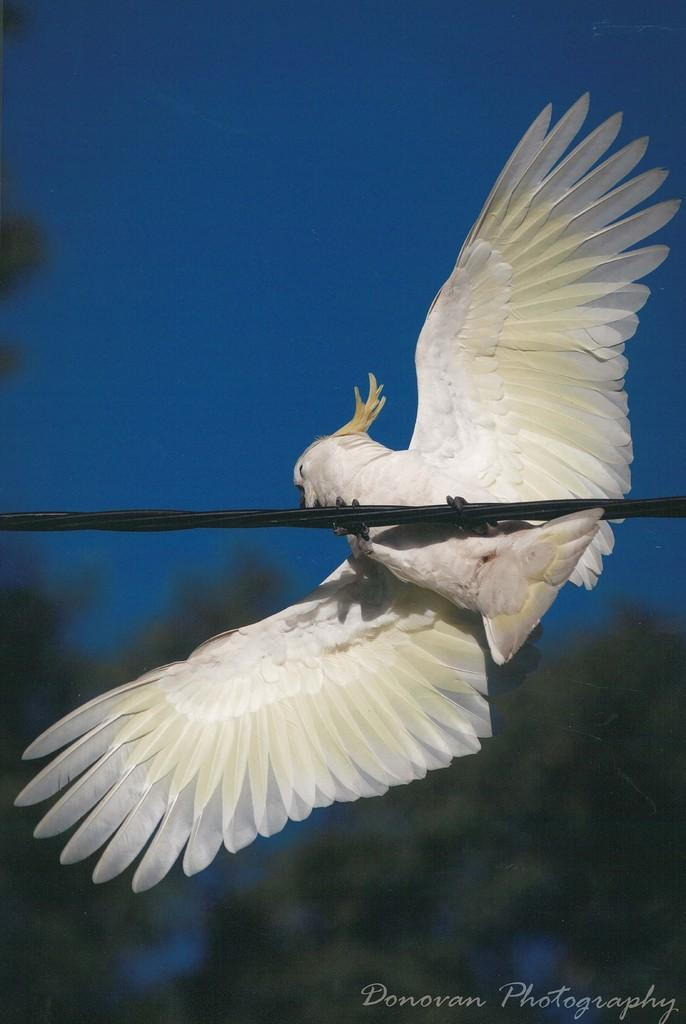What type of animal can be seen in the image? There is a white bird in the image. Where is the bird located? The bird is on a wire. Can you describe the background of the image? The background of the image is blurred. Is there any additional information or markings in the image? Yes, there is a watermark in the right bottom corner of the image. What type of plantation can be seen in the background of the image? There is no plantation visible in the image; the background is blurred. What scent is associated with the bird in the image? There is no information about the scent of the bird or the image, as the focus is on the visual aspects. 